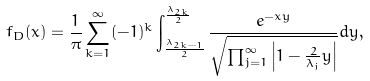<formula> <loc_0><loc_0><loc_500><loc_500>f _ { D } ( x ) = \frac { 1 } { \pi } \sum _ { k = 1 } ^ { \infty } ( - 1 ) ^ { k } \int _ { \frac { \lambda _ { 2 k - 1 } } { 2 } } ^ { \frac { \lambda _ { 2 k } } { 2 } } \frac { e ^ { - x y } } { \sqrt { \prod _ { j = 1 } ^ { \infty } \left | 1 - \frac { 2 } { \lambda _ { j } } y \right | } } d y ,</formula> 